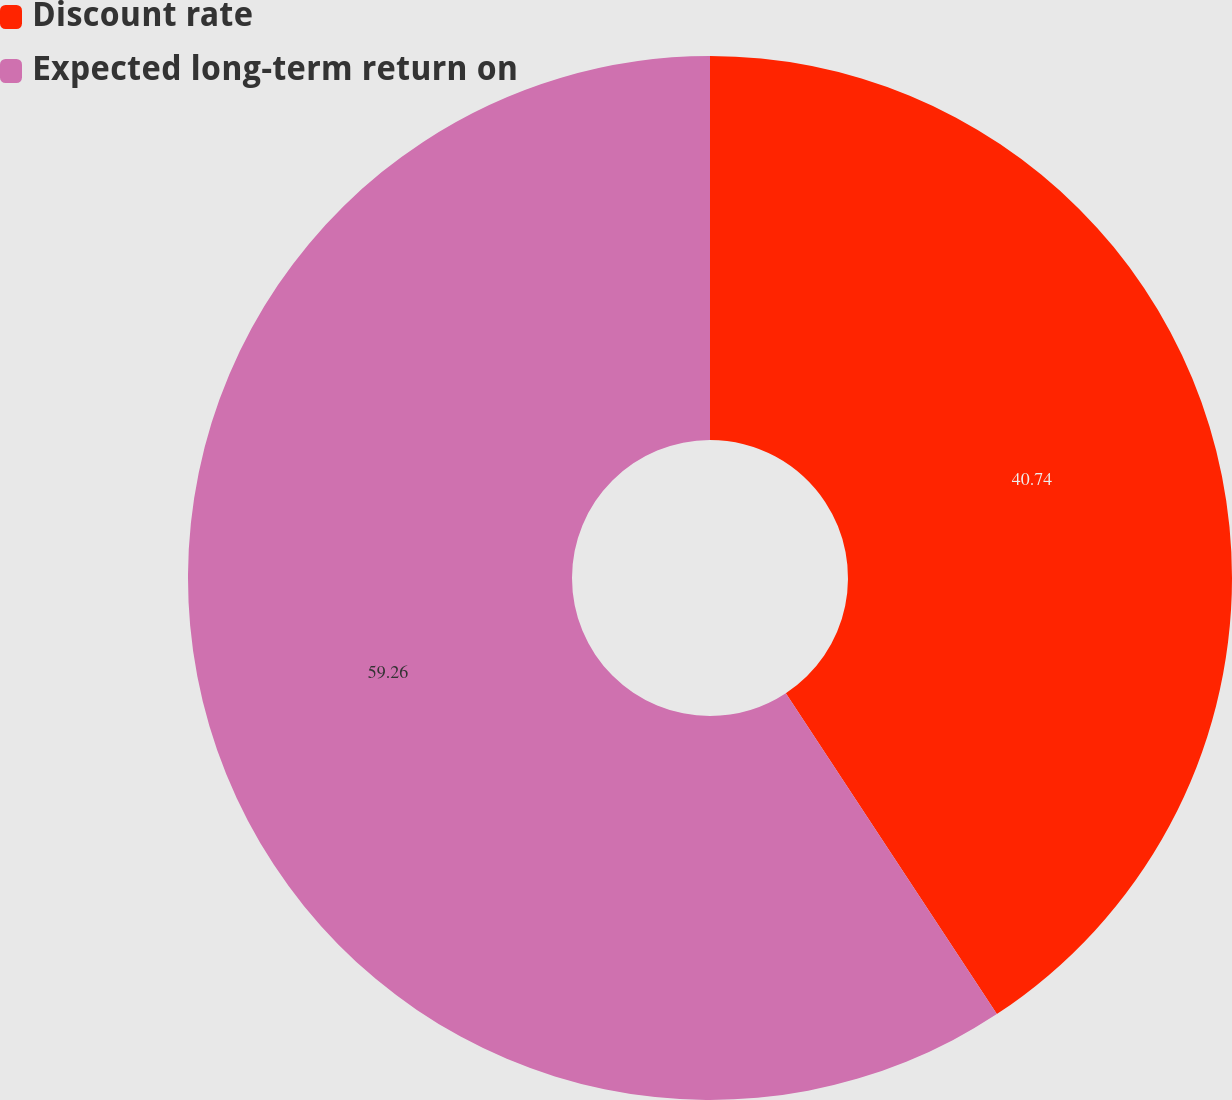Convert chart to OTSL. <chart><loc_0><loc_0><loc_500><loc_500><pie_chart><fcel>Discount rate<fcel>Expected long-term return on<nl><fcel>40.74%<fcel>59.26%<nl></chart> 